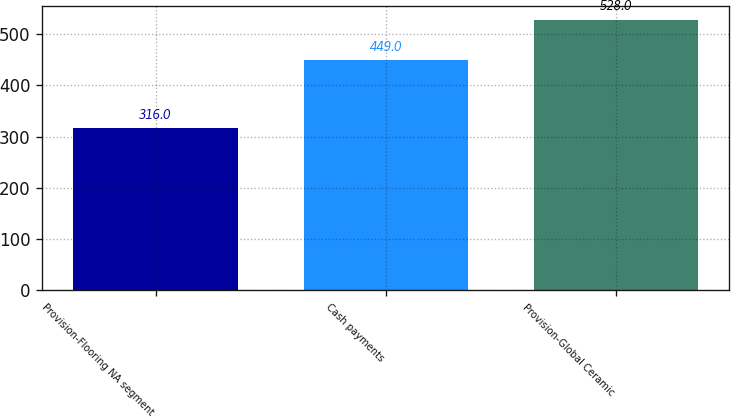Convert chart. <chart><loc_0><loc_0><loc_500><loc_500><bar_chart><fcel>Provision-Flooring NA segment<fcel>Cash payments<fcel>Provision-Global Ceramic<nl><fcel>316<fcel>449<fcel>528<nl></chart> 